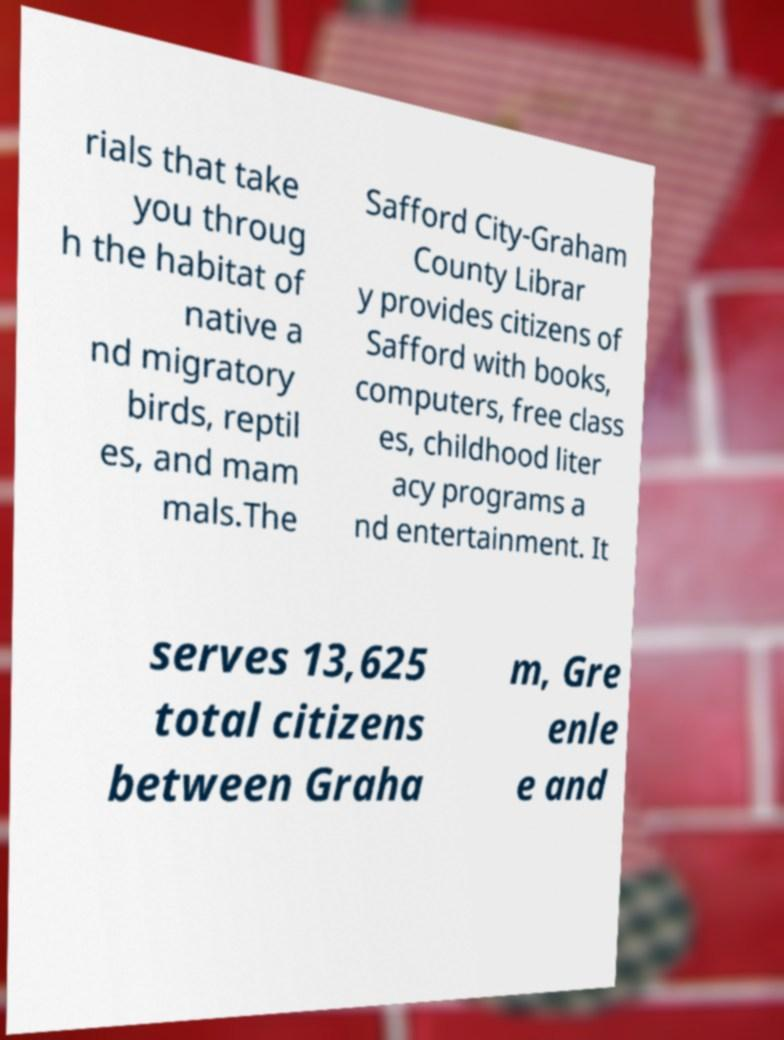For documentation purposes, I need the text within this image transcribed. Could you provide that? rials that take you throug h the habitat of native a nd migratory birds, reptil es, and mam mals.The Safford City-Graham County Librar y provides citizens of Safford with books, computers, free class es, childhood liter acy programs a nd entertainment. It serves 13,625 total citizens between Graha m, Gre enle e and 